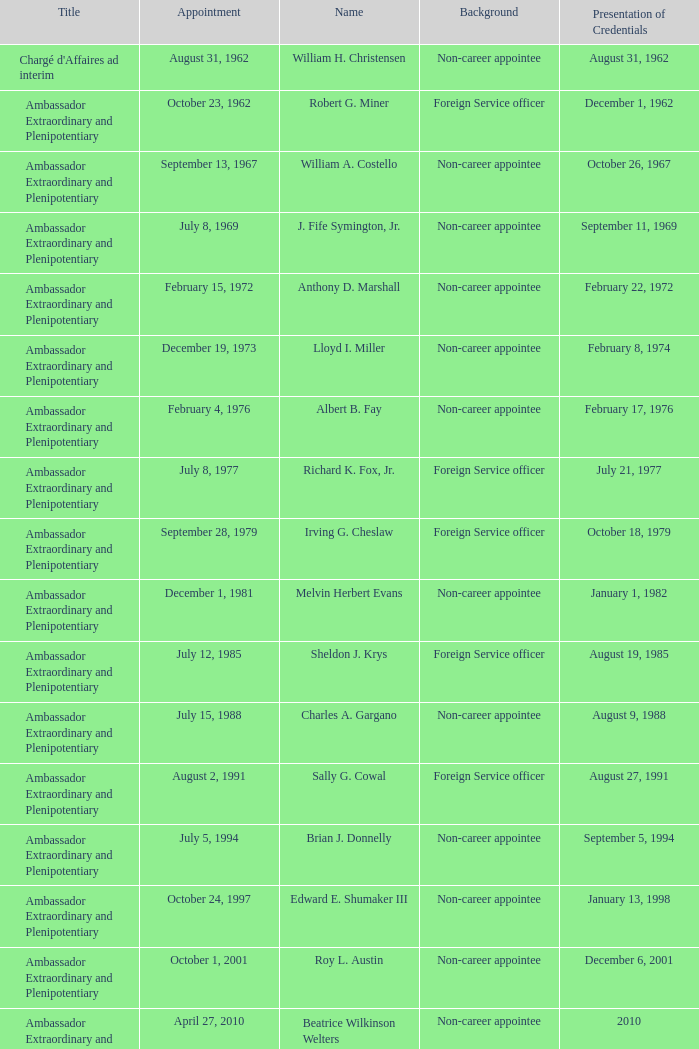What was Anthony D. Marshall's title? Ambassador Extraordinary and Plenipotentiary. 